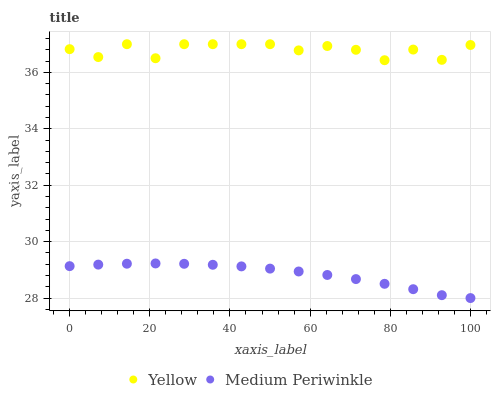Does Medium Periwinkle have the minimum area under the curve?
Answer yes or no. Yes. Does Yellow have the maximum area under the curve?
Answer yes or no. Yes. Does Yellow have the minimum area under the curve?
Answer yes or no. No. Is Medium Periwinkle the smoothest?
Answer yes or no. Yes. Is Yellow the roughest?
Answer yes or no. Yes. Is Yellow the smoothest?
Answer yes or no. No. Does Medium Periwinkle have the lowest value?
Answer yes or no. Yes. Does Yellow have the lowest value?
Answer yes or no. No. Does Yellow have the highest value?
Answer yes or no. Yes. Is Medium Periwinkle less than Yellow?
Answer yes or no. Yes. Is Yellow greater than Medium Periwinkle?
Answer yes or no. Yes. Does Medium Periwinkle intersect Yellow?
Answer yes or no. No. 